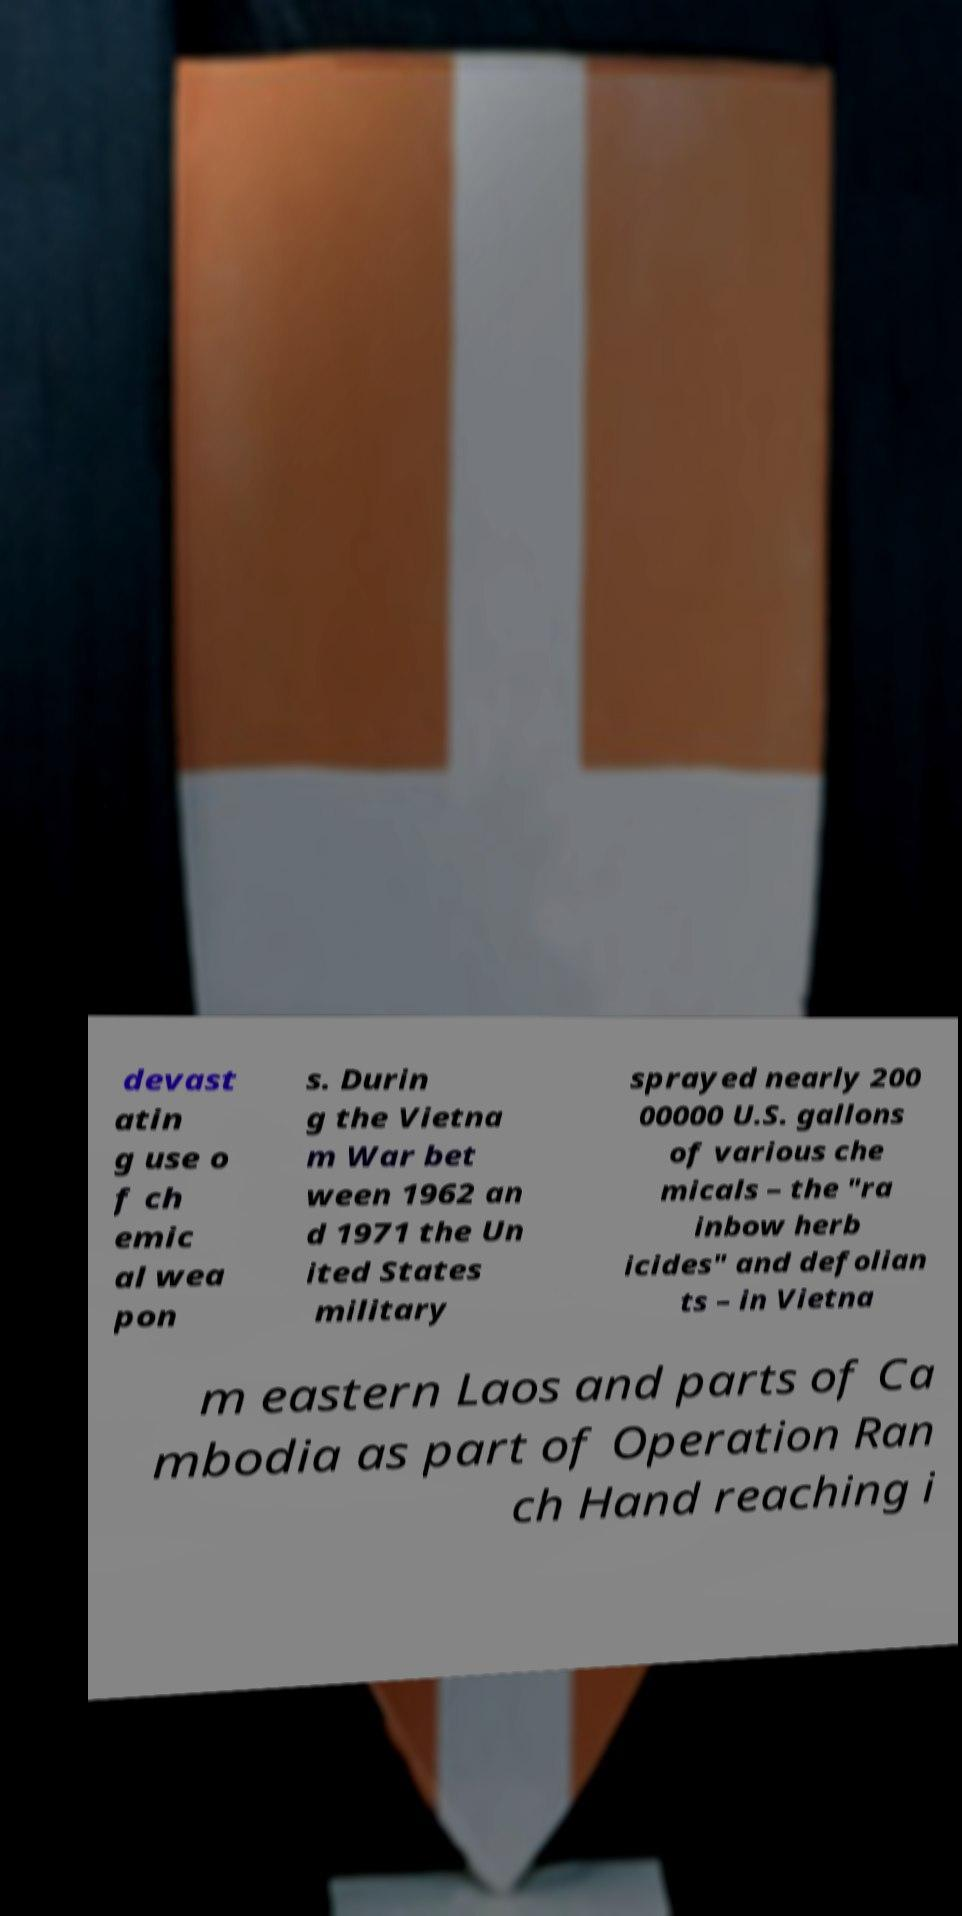Could you assist in decoding the text presented in this image and type it out clearly? devast atin g use o f ch emic al wea pon s. Durin g the Vietna m War bet ween 1962 an d 1971 the Un ited States military sprayed nearly 200 00000 U.S. gallons of various che micals – the "ra inbow herb icides" and defolian ts – in Vietna m eastern Laos and parts of Ca mbodia as part of Operation Ran ch Hand reaching i 